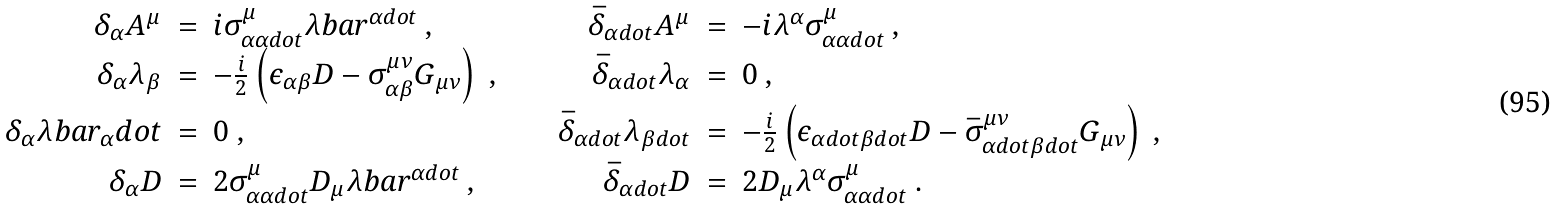Convert formula to latex. <formula><loc_0><loc_0><loc_500><loc_500>\begin{array} { r c l c r c l } \delta _ { \alpha } A ^ { \mu } & = & i \sigma ^ { \mu } _ { \alpha \alpha d o t } \lambda b a r ^ { \alpha d o t } \ , & \quad & \bar { \delta } _ { \alpha d o t } A ^ { \mu } & = & - i \lambda ^ { \alpha } \sigma ^ { \mu } _ { \alpha \alpha d o t } \ , \\ \delta _ { \alpha } \lambda _ { \beta } & = & - \frac { i } { 2 } \left ( \epsilon _ { \alpha \beta } D - \sigma ^ { \mu \nu } _ { \alpha \beta } G _ { \mu \nu } \right ) \ , & \quad & \bar { \delta } _ { \alpha d o t } \lambda _ { \alpha } & = & 0 \ , \\ \delta _ { \alpha } \lambda b a r _ { \alpha } d o t & = & 0 \ , & \quad & \bar { \delta } _ { \alpha d o t } \lambda _ { \beta d o t } & = & - \frac { i } { 2 } \left ( \epsilon _ { \alpha d o t \beta d o t } D - \bar { \sigma } ^ { \mu \nu } _ { \alpha d o t \beta d o t } G _ { \mu \nu } \right ) \ , \\ \delta _ { \alpha } D & = & 2 \sigma ^ { \mu } _ { \alpha \alpha d o t } D _ { \mu } \lambda b a r ^ { \alpha d o t } \ , & \quad & \bar { \delta } _ { \alpha d o t } D & = & 2 D _ { \mu } \lambda ^ { \alpha } \sigma ^ { \mu } _ { \alpha \alpha d o t } \ . \end{array}</formula> 